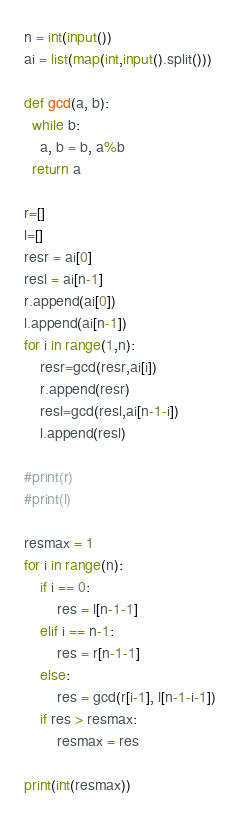Convert code to text. <code><loc_0><loc_0><loc_500><loc_500><_Python_>n = int(input())
ai = list(map(int,input().split()))

def gcd(a, b):
  while b:
    a, b = b, a%b
  return a

r=[]
l=[]
resr = ai[0]
resl = ai[n-1]
r.append(ai[0])
l.append(ai[n-1])
for i in range(1,n):
	resr=gcd(resr,ai[i])
	r.append(resr)
	resl=gcd(resl,ai[n-1-i])
	l.append(resl)

#print(r)
#print(l)

resmax = 1
for i in range(n):
	if i == 0:
		res = l[n-1-1]
	elif i == n-1:
		res = r[n-1-1]
	else:
		res = gcd(r[i-1], l[n-1-i-1])
	if res > resmax:
		resmax = res

print(int(resmax))</code> 